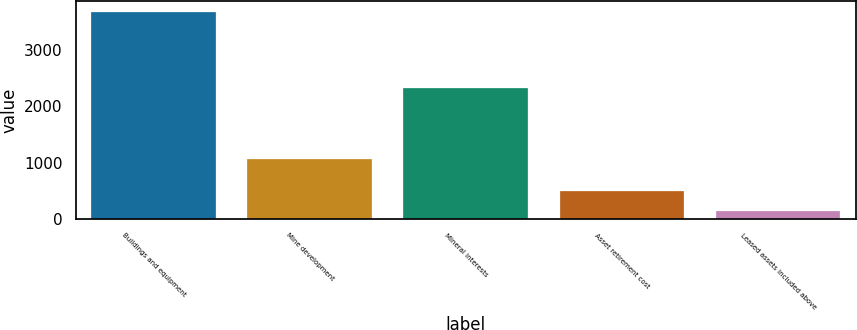Convert chart to OTSL. <chart><loc_0><loc_0><loc_500><loc_500><bar_chart><fcel>Buildings and equipment<fcel>Mine development<fcel>Mineral interests<fcel>Asset retirement cost<fcel>Leased assets included above<nl><fcel>3676<fcel>1055<fcel>2321<fcel>502.6<fcel>150<nl></chart> 